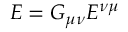<formula> <loc_0><loc_0><loc_500><loc_500>E = G _ { \mu \nu } E ^ { \nu \mu }</formula> 